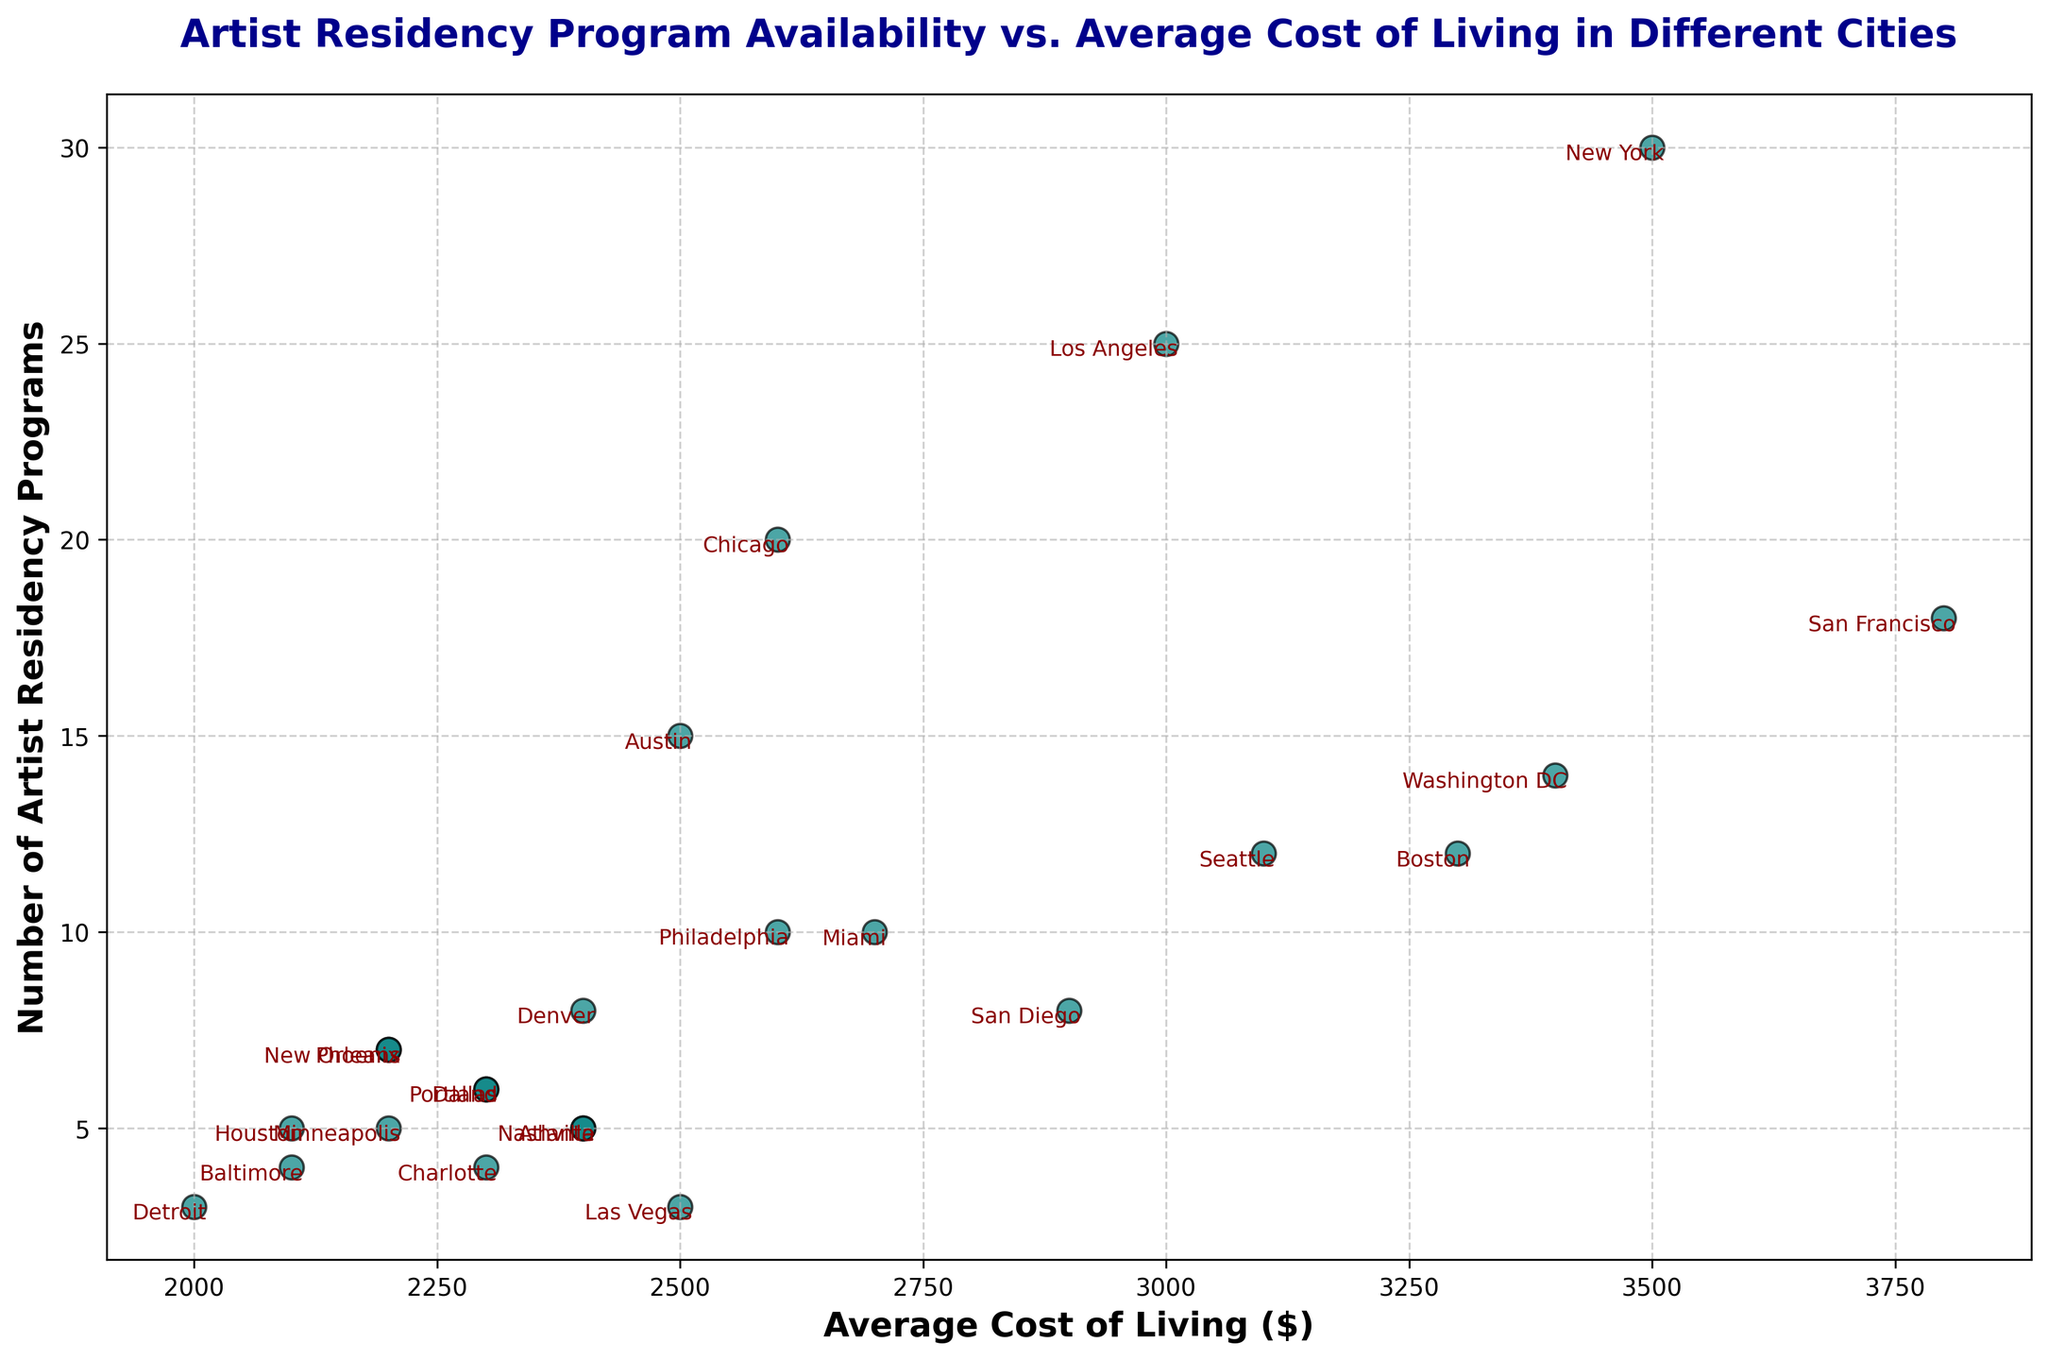Which city has the highest average cost of living and how many artist residency programs does it have? San Francisco has the highest average cost of living at $3800. Checking alongside, it shows 18 artist residency programs available in San Francisco.
Answer: San Francisco, 18 Which city has the lowest number of artist residency programs and what is its average cost of living? Detroit has the lowest number of artist residency programs, which is 3. Looking at the plot, the average cost of living in Detroit is $2000.
Answer: Detroit, $2000 Compare the number of artist residency programs between New York and Los Angeles. New York has 30 artist residency programs, while Los Angeles has 25 as indicated by their data points on the scatter plot.
Answer: New York has 5 more residency programs than Los Angeles What is the average number of artist residency programs for cities with an average cost of living above $3000? There are four cities with an average cost of living above $3000: New York (30), San Francisco (18), Boston (12), and Washington DC (14). Summing these up gives 30 + 18 + 12 + 14 = 74. Dividing by the number of these cities, 74 / 4 = 18.5
Answer: 18.5 Which city has a similar number of artist residency programs to Philadelphia but a lower average cost of living? Both Phoenix and New Orleans have 7 artist residency programs similar to Philadelphia (which has 10). Among these, Phoenix has the lower average cost of living at $2200 compared to New Orleans also at $2200.
Answer: Phoenix or New Orleans Identify a city with an average cost of living near $2500 and describe its number of artist residency programs. Denver has an average cost of living of $2400 and 8 artist residency programs, Las Vegas shows $2500 and 3 artist residency programs. Additionally, Austin at $2500 offers 15 artist residency programs. Hence, Austin provides notably more residencies.
Answer: Austin, 15 Calculate the sum of artist residency programs for Seattle, Miami, and Portland. Seattle has 12 artist residency programs, Miami has 10, and Portland has 6. Summing these numbers up gives 12 + 10 + 6 = 28.
Answer: 28 Is there a city with a higher number of artist residency programs but a lower average cost of living than Austin? No, Austin has 15 artist residency programs and an average cost of living of $2500. No city with more than 15 programs has a lower cost of living.
Answer: No 